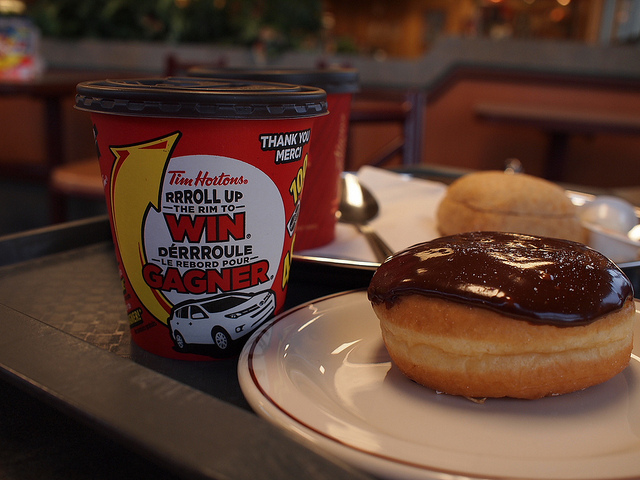Please transcribe the text in this image. THANK YOU MERCI Tim 4 GAGNER POUR REBORD LE DERRROULE WIN TO RIM THE UP RRROLL Hortons 